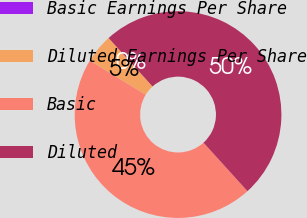Convert chart to OTSL. <chart><loc_0><loc_0><loc_500><loc_500><pie_chart><fcel>Basic Earnings Per Share<fcel>Diluted Earnings Per Share<fcel>Basic<fcel>Diluted<nl><fcel>0.0%<fcel>4.55%<fcel>45.45%<fcel>50.0%<nl></chart> 